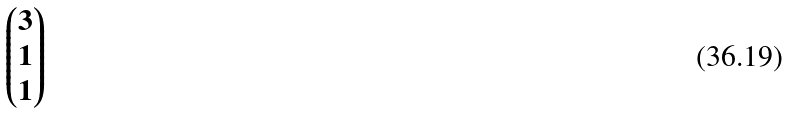Convert formula to latex. <formula><loc_0><loc_0><loc_500><loc_500>\begin{pmatrix} 3 \\ 1 \\ 1 \end{pmatrix}</formula> 